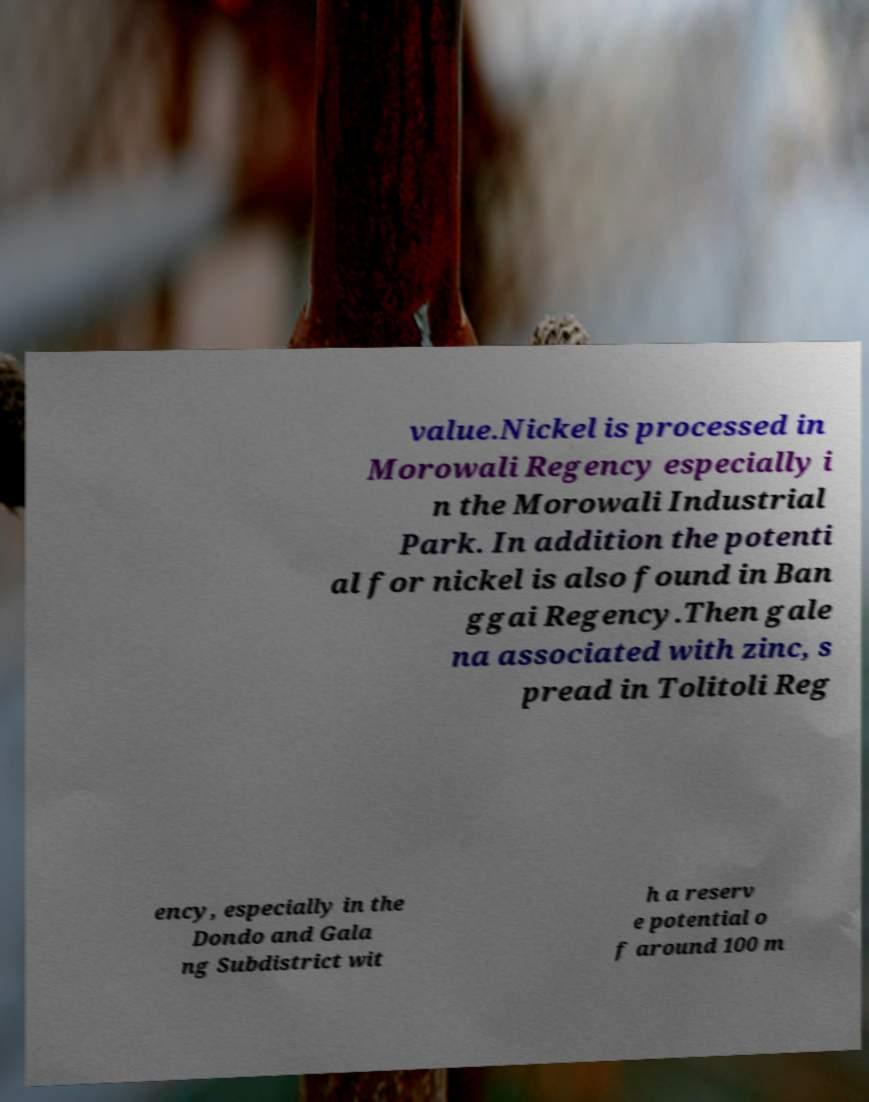Could you assist in decoding the text presented in this image and type it out clearly? value.Nickel is processed in Morowali Regency especially i n the Morowali Industrial Park. In addition the potenti al for nickel is also found in Ban ggai Regency.Then gale na associated with zinc, s pread in Tolitoli Reg ency, especially in the Dondo and Gala ng Subdistrict wit h a reserv e potential o f around 100 m 